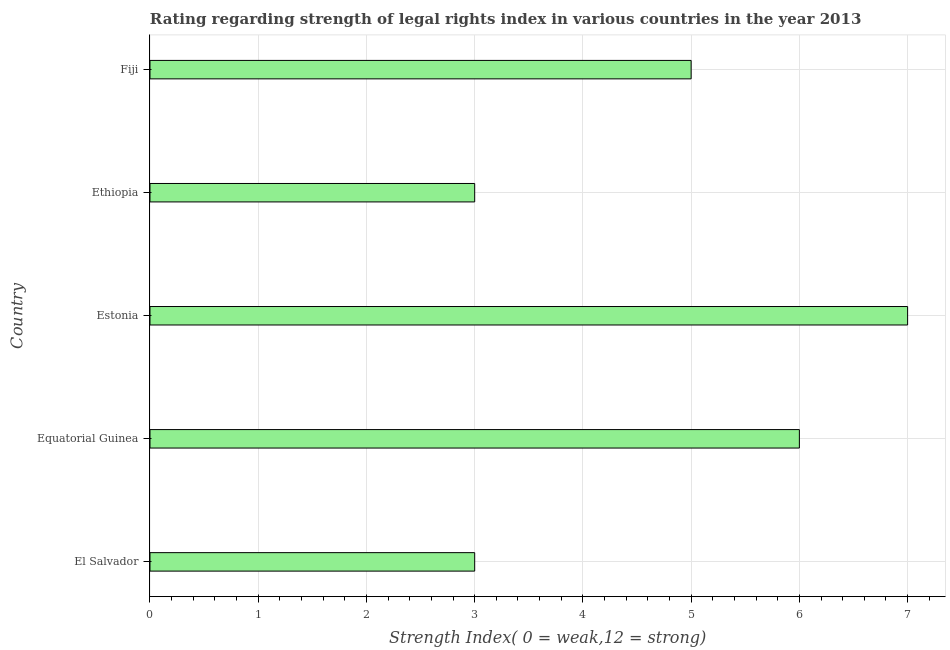Does the graph contain grids?
Provide a short and direct response. Yes. What is the title of the graph?
Your answer should be very brief. Rating regarding strength of legal rights index in various countries in the year 2013. What is the label or title of the X-axis?
Make the answer very short. Strength Index( 0 = weak,12 = strong). What is the label or title of the Y-axis?
Your answer should be very brief. Country. Across all countries, what is the maximum strength of legal rights index?
Offer a very short reply. 7. In which country was the strength of legal rights index maximum?
Provide a short and direct response. Estonia. In which country was the strength of legal rights index minimum?
Provide a succinct answer. El Salvador. What is the difference between the strength of legal rights index in Equatorial Guinea and Fiji?
Your response must be concise. 1. What is the median strength of legal rights index?
Keep it short and to the point. 5. In how many countries, is the strength of legal rights index greater than 5.8 ?
Your response must be concise. 2. Is the difference between the strength of legal rights index in Equatorial Guinea and Ethiopia greater than the difference between any two countries?
Offer a terse response. No. How many bars are there?
Offer a terse response. 5. Are all the bars in the graph horizontal?
Ensure brevity in your answer.  Yes. How many countries are there in the graph?
Offer a terse response. 5. What is the difference between two consecutive major ticks on the X-axis?
Keep it short and to the point. 1. What is the Strength Index( 0 = weak,12 = strong) of Ethiopia?
Make the answer very short. 3. What is the difference between the Strength Index( 0 = weak,12 = strong) in El Salvador and Estonia?
Provide a succinct answer. -4. What is the difference between the Strength Index( 0 = weak,12 = strong) in El Salvador and Fiji?
Keep it short and to the point. -2. What is the difference between the Strength Index( 0 = weak,12 = strong) in Equatorial Guinea and Ethiopia?
Your response must be concise. 3. What is the difference between the Strength Index( 0 = weak,12 = strong) in Equatorial Guinea and Fiji?
Your answer should be compact. 1. What is the difference between the Strength Index( 0 = weak,12 = strong) in Estonia and Fiji?
Your response must be concise. 2. What is the difference between the Strength Index( 0 = weak,12 = strong) in Ethiopia and Fiji?
Your answer should be very brief. -2. What is the ratio of the Strength Index( 0 = weak,12 = strong) in El Salvador to that in Equatorial Guinea?
Your answer should be compact. 0.5. What is the ratio of the Strength Index( 0 = weak,12 = strong) in El Salvador to that in Estonia?
Your response must be concise. 0.43. What is the ratio of the Strength Index( 0 = weak,12 = strong) in El Salvador to that in Ethiopia?
Ensure brevity in your answer.  1. What is the ratio of the Strength Index( 0 = weak,12 = strong) in Equatorial Guinea to that in Estonia?
Your answer should be very brief. 0.86. What is the ratio of the Strength Index( 0 = weak,12 = strong) in Estonia to that in Ethiopia?
Provide a short and direct response. 2.33. What is the ratio of the Strength Index( 0 = weak,12 = strong) in Estonia to that in Fiji?
Provide a succinct answer. 1.4. What is the ratio of the Strength Index( 0 = weak,12 = strong) in Ethiopia to that in Fiji?
Your response must be concise. 0.6. 